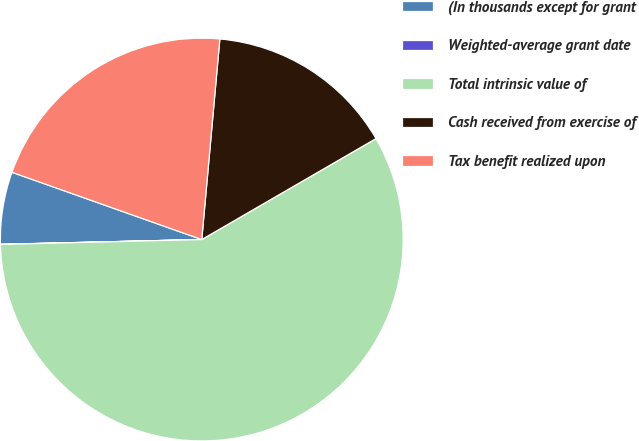Convert chart to OTSL. <chart><loc_0><loc_0><loc_500><loc_500><pie_chart><fcel>(In thousands except for grant<fcel>Weighted-average grant date<fcel>Total intrinsic value of<fcel>Cash received from exercise of<fcel>Tax benefit realized upon<nl><fcel>5.8%<fcel>0.01%<fcel>57.97%<fcel>15.21%<fcel>21.01%<nl></chart> 